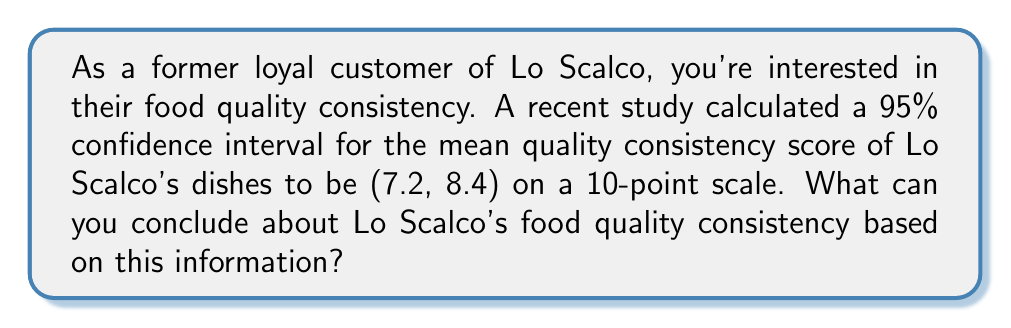Help me with this question. To interpret this confidence interval, let's break it down step-by-step:

1) The confidence interval is given as (7.2, 8.4) with a 95% confidence level.

2) Interpretation of a confidence interval:
   We can be 95% confident that the true population mean quality consistency score falls between 7.2 and 8.4 on a 10-point scale.

3) Lower bound analysis:
   $7.2 / 10 = 0.72$ or 72% of the maximum score

4) Upper bound analysis:
   $8.4 / 10 = 0.84$ or 84% of the maximum score

5) Midpoint of the interval:
   $(7.2 + 8.4) / 2 = 7.8$

6) Width of the interval:
   $8.4 - 7.2 = 1.2$

7) Interpretation:
   - The mean quality consistency score is likely above 7 out of 10, indicating above-average consistency.
   - The interval doesn't include extremely low or high values, suggesting moderate to good consistency.
   - The width of 1.2 points indicates a reasonable level of precision in the estimate.

Therefore, we can conclude that Lo Scalco maintains a good to very good level of food quality consistency, with the true average score likely falling between 72% and 84% of the maximum possible score.
Answer: Lo Scalco maintains good to very good food quality consistency, with the true average score likely between 72% and 84% of the maximum. 